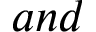<formula> <loc_0><loc_0><loc_500><loc_500>a n d</formula> 